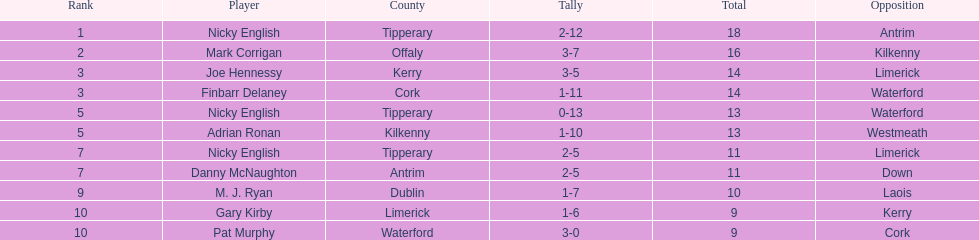Who managed to get 10 cumulative points in their game? M. J. Ryan. 